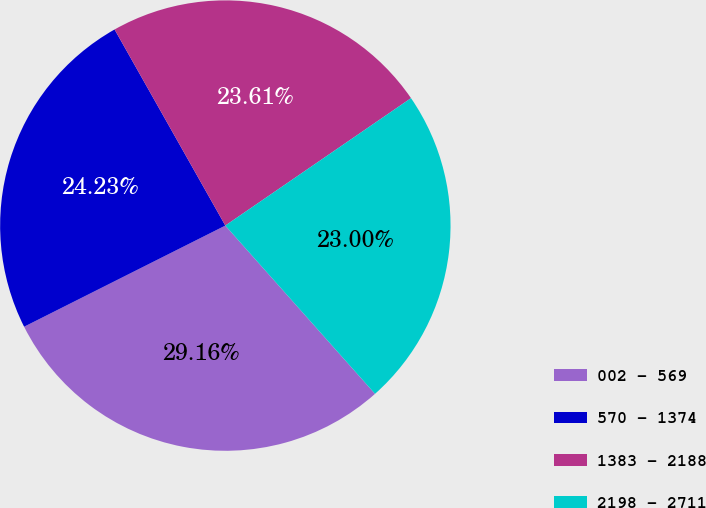Convert chart to OTSL. <chart><loc_0><loc_0><loc_500><loc_500><pie_chart><fcel>002 - 569<fcel>570 - 1374<fcel>1383 - 2188<fcel>2198 - 2711<nl><fcel>29.16%<fcel>24.23%<fcel>23.61%<fcel>23.0%<nl></chart> 